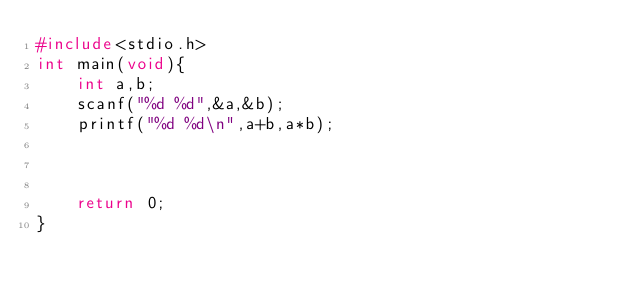Convert code to text. <code><loc_0><loc_0><loc_500><loc_500><_C_>#include<stdio.h>
int main(void){
    int a,b;
    scanf("%d %d",&a,&b);
    printf("%d %d\n",a+b,a*b);



    return 0;
}</code> 